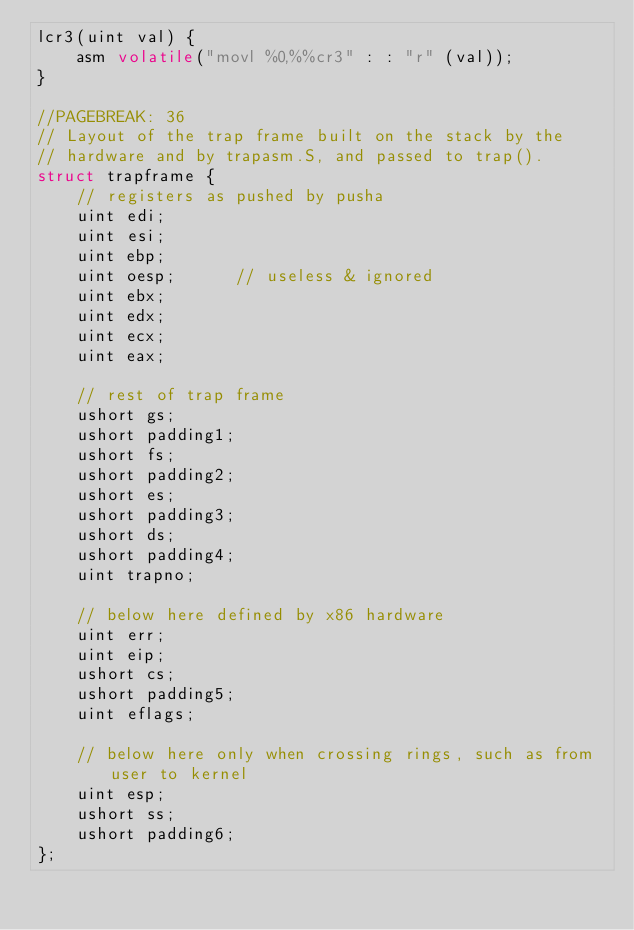Convert code to text. <code><loc_0><loc_0><loc_500><loc_500><_C_>lcr3(uint val) {
    asm volatile("movl %0,%%cr3" : : "r" (val));
}

//PAGEBREAK: 36
// Layout of the trap frame built on the stack by the
// hardware and by trapasm.S, and passed to trap().
struct trapframe {
    // registers as pushed by pusha
    uint edi;
    uint esi;
    uint ebp;
    uint oesp;      // useless & ignored
    uint ebx;
    uint edx;
    uint ecx;
    uint eax;

    // rest of trap frame
    ushort gs;
    ushort padding1;
    ushort fs;
    ushort padding2;
    ushort es;
    ushort padding3;
    ushort ds;
    ushort padding4;
    uint trapno;

    // below here defined by x86 hardware
    uint err;
    uint eip;
    ushort cs;
    ushort padding5;
    uint eflags;

    // below here only when crossing rings, such as from user to kernel
    uint esp;
    ushort ss;
    ushort padding6;
};
</code> 